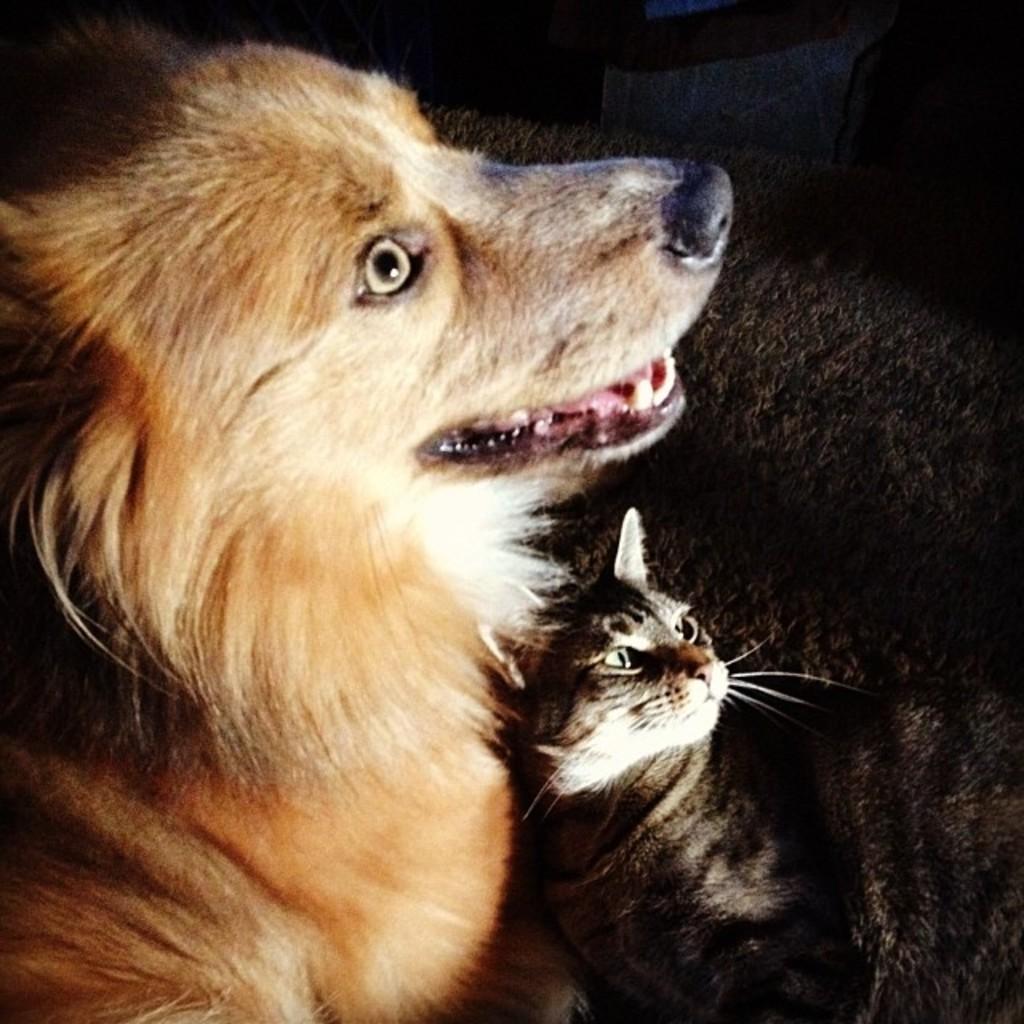In one or two sentences, can you explain what this image depicts? In this image we can see the animals on the ground and dark background. 